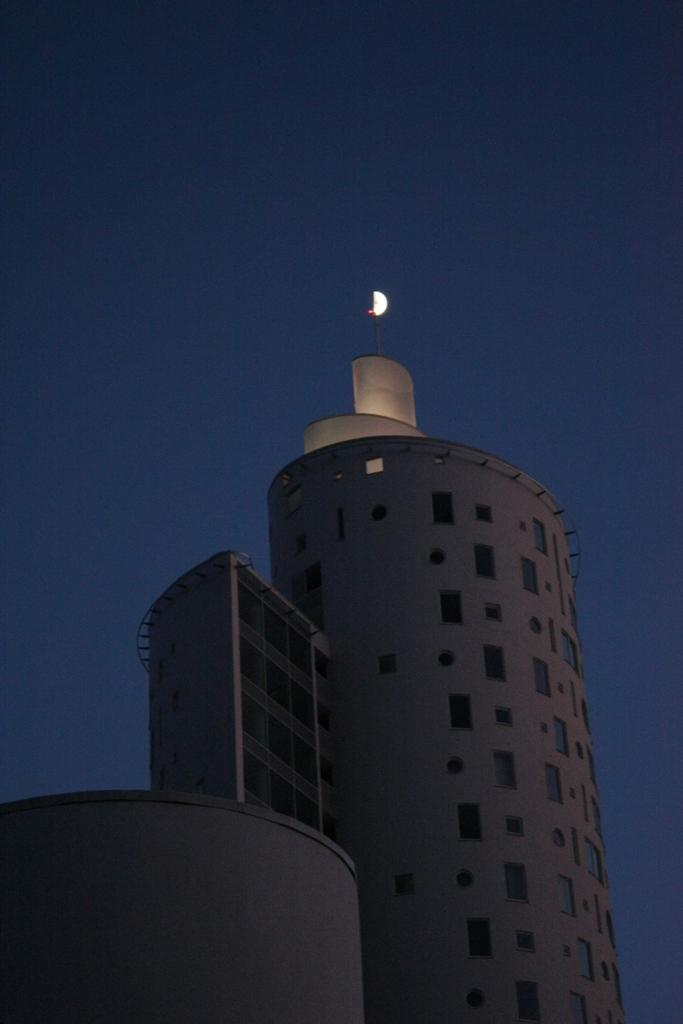What is the main structure in the image? There is a building in the image. What feature can be seen on the building? The building has windows. What celestial object is visible in the background of the image? The moon is visible in the sky in the background of the image. Can you see a receipt on the ground near the building in the image? There is no mention of a receipt in the image, so it cannot be confirmed or denied. 